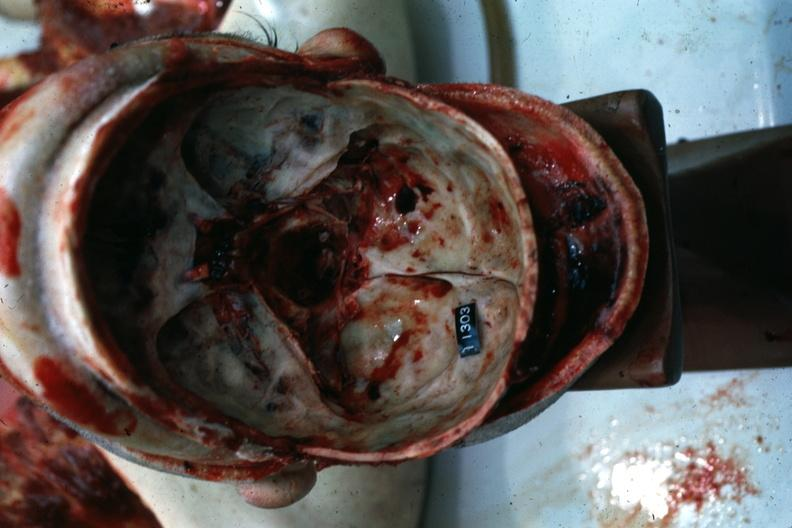what does this image show?
Answer the question using a single word or phrase. Multiple fractures 